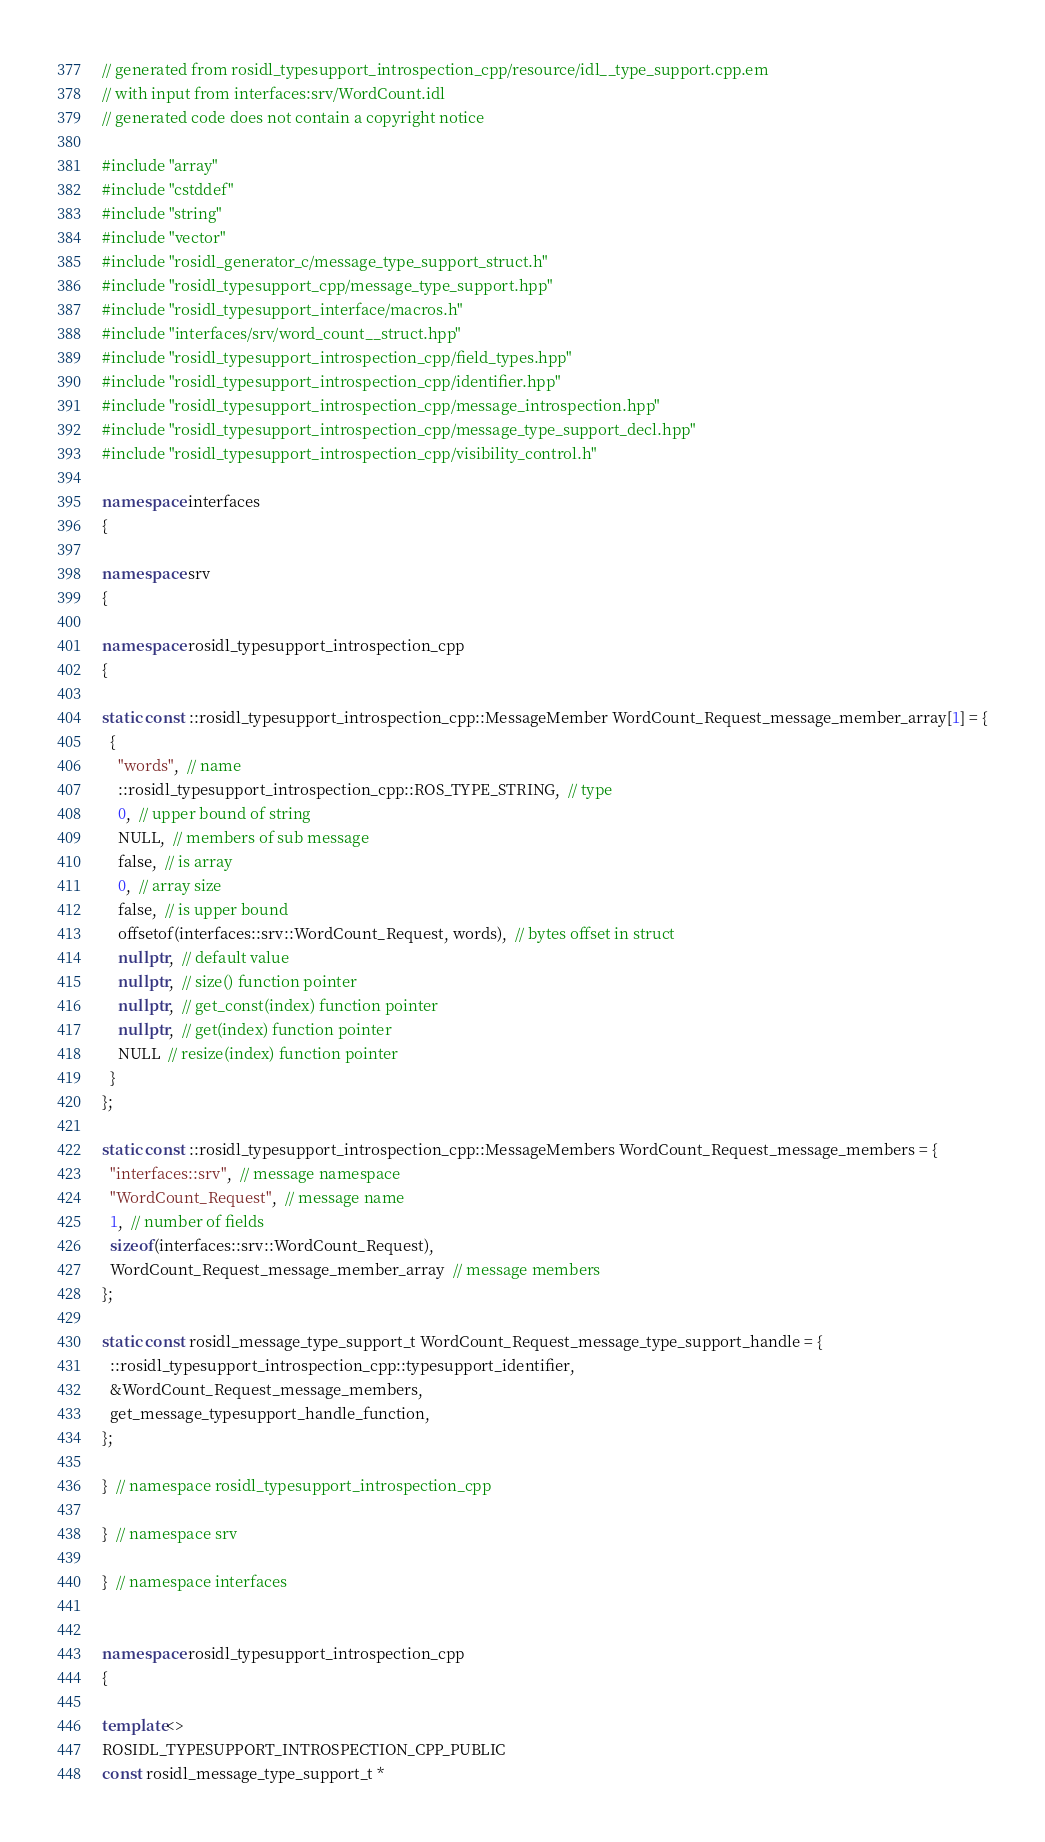Convert code to text. <code><loc_0><loc_0><loc_500><loc_500><_C++_>// generated from rosidl_typesupport_introspection_cpp/resource/idl__type_support.cpp.em
// with input from interfaces:srv/WordCount.idl
// generated code does not contain a copyright notice

#include "array"
#include "cstddef"
#include "string"
#include "vector"
#include "rosidl_generator_c/message_type_support_struct.h"
#include "rosidl_typesupport_cpp/message_type_support.hpp"
#include "rosidl_typesupport_interface/macros.h"
#include "interfaces/srv/word_count__struct.hpp"
#include "rosidl_typesupport_introspection_cpp/field_types.hpp"
#include "rosidl_typesupport_introspection_cpp/identifier.hpp"
#include "rosidl_typesupport_introspection_cpp/message_introspection.hpp"
#include "rosidl_typesupport_introspection_cpp/message_type_support_decl.hpp"
#include "rosidl_typesupport_introspection_cpp/visibility_control.h"

namespace interfaces
{

namespace srv
{

namespace rosidl_typesupport_introspection_cpp
{

static const ::rosidl_typesupport_introspection_cpp::MessageMember WordCount_Request_message_member_array[1] = {
  {
    "words",  // name
    ::rosidl_typesupport_introspection_cpp::ROS_TYPE_STRING,  // type
    0,  // upper bound of string
    NULL,  // members of sub message
    false,  // is array
    0,  // array size
    false,  // is upper bound
    offsetof(interfaces::srv::WordCount_Request, words),  // bytes offset in struct
    nullptr,  // default value
    nullptr,  // size() function pointer
    nullptr,  // get_const(index) function pointer
    nullptr,  // get(index) function pointer
    NULL  // resize(index) function pointer
  }
};

static const ::rosidl_typesupport_introspection_cpp::MessageMembers WordCount_Request_message_members = {
  "interfaces::srv",  // message namespace
  "WordCount_Request",  // message name
  1,  // number of fields
  sizeof(interfaces::srv::WordCount_Request),
  WordCount_Request_message_member_array  // message members
};

static const rosidl_message_type_support_t WordCount_Request_message_type_support_handle = {
  ::rosidl_typesupport_introspection_cpp::typesupport_identifier,
  &WordCount_Request_message_members,
  get_message_typesupport_handle_function,
};

}  // namespace rosidl_typesupport_introspection_cpp

}  // namespace srv

}  // namespace interfaces


namespace rosidl_typesupport_introspection_cpp
{

template<>
ROSIDL_TYPESUPPORT_INTROSPECTION_CPP_PUBLIC
const rosidl_message_type_support_t *</code> 